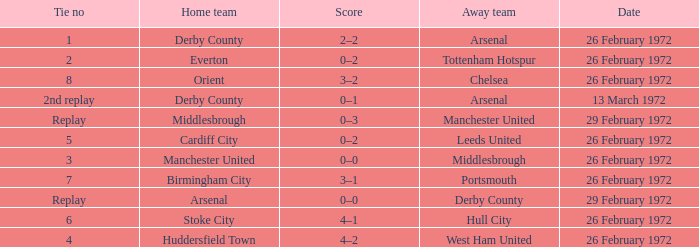Which Tie is from birmingham city? 7.0. 